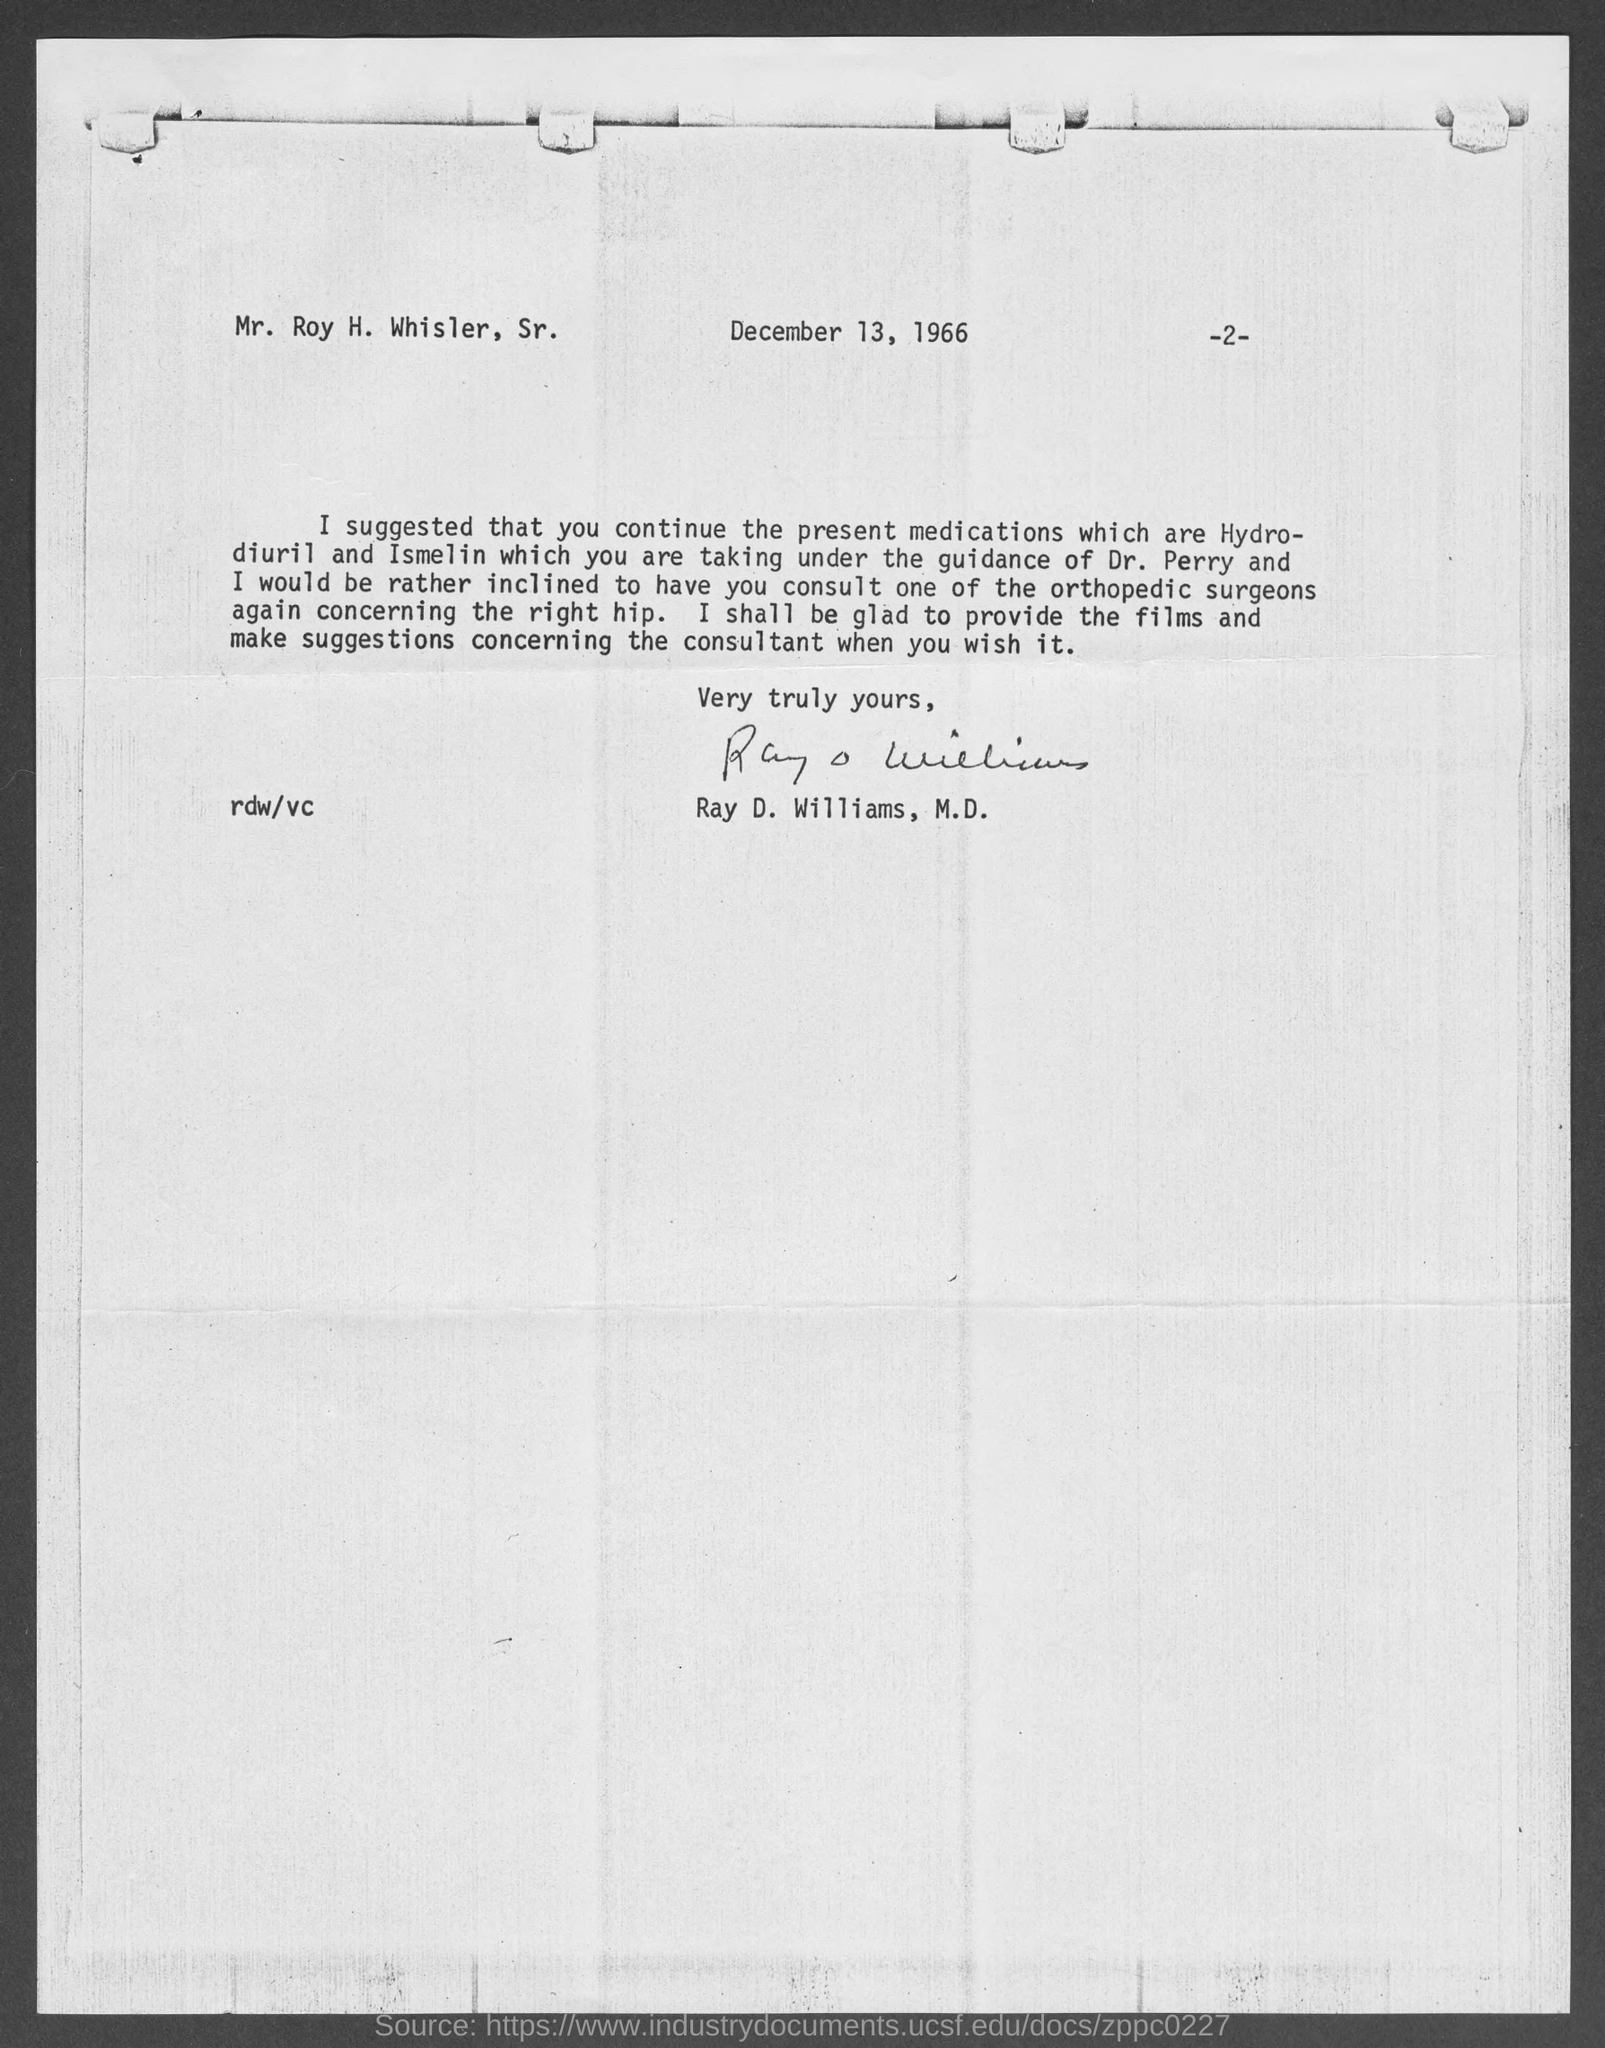When is the memorandum dated on ?
Your answer should be very brief. December 13, 1966. Who is the memorandum from ?
Make the answer very short. Ray D. Williams, M.D. 